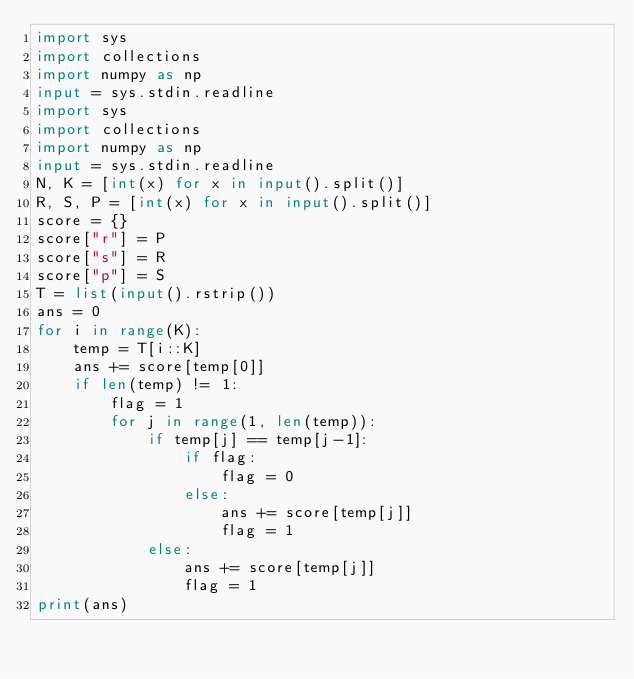<code> <loc_0><loc_0><loc_500><loc_500><_Python_>import sys
import collections
import numpy as np
input = sys.stdin.readline
import sys
import collections
import numpy as np
input = sys.stdin.readline
N, K = [int(x) for x in input().split()]
R, S, P = [int(x) for x in input().split()]
score = {}
score["r"] = P
score["s"] = R
score["p"] = S
T = list(input().rstrip())
ans = 0
for i in range(K):
    temp = T[i::K]
    ans += score[temp[0]]
    if len(temp) != 1:
        flag = 1
        for j in range(1, len(temp)):
            if temp[j] == temp[j-1]:
                if flag:
                    flag = 0
                else:
                    ans += score[temp[j]]
                    flag = 1
            else:
                ans += score[temp[j]]
                flag = 1
print(ans)
</code> 